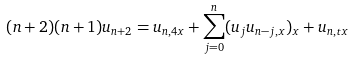Convert formula to latex. <formula><loc_0><loc_0><loc_500><loc_500>( n + 2 ) ( n + 1 ) u _ { n + 2 } = u _ { n , 4 x } + \sum _ { j = 0 } ^ { n } ( u _ { j } u _ { n - j , x } ) _ { x } + u _ { n , t x }</formula> 